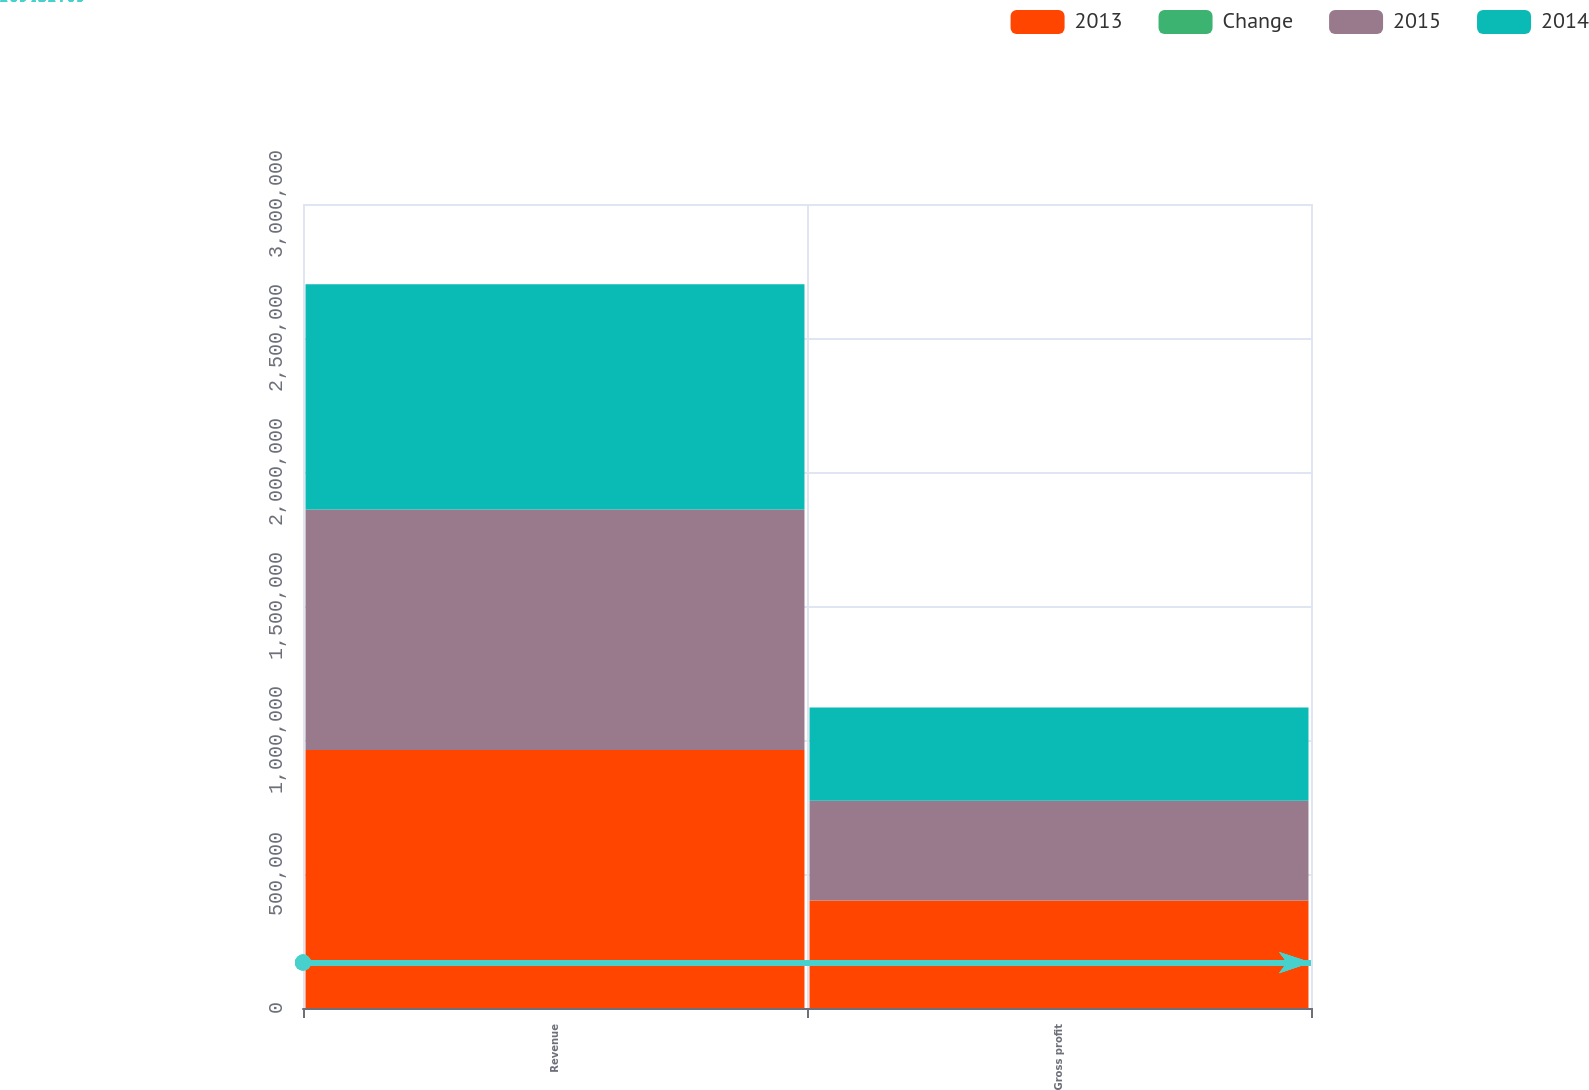Convert chart to OTSL. <chart><loc_0><loc_0><loc_500><loc_500><stacked_bar_chart><ecel><fcel>Revenue<fcel>Gross profit<nl><fcel>2013<fcel>962729<fcel>400659<nl><fcel>Change<fcel>7<fcel>8<nl><fcel>2015<fcel>897671<fcel>372473<nl><fcel>2014<fcel>840380<fcel>348309<nl></chart> 